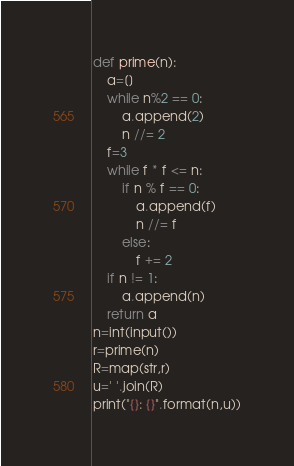Convert code to text. <code><loc_0><loc_0><loc_500><loc_500><_Python_>def prime(n):
    a=[]
    while n%2 == 0:
        a.append(2)
        n //= 2
    f=3
    while f * f <= n:
        if n % f == 0:
            a.append(f)
            n //= f
        else:
            f += 2
    if n != 1:
        a.append(n)
    return a
n=int(input())
r=prime(n)
R=map(str,r)
u=' '.join(R)
print("{}: {}".format(n,u))
</code> 